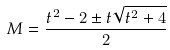Convert formula to latex. <formula><loc_0><loc_0><loc_500><loc_500>M = \frac { t ^ { 2 } - 2 \pm t \sqrt { t ^ { 2 } + 4 } } { 2 }</formula> 